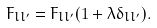<formula> <loc_0><loc_0><loc_500><loc_500>F _ { l l ^ { \prime } } = F _ { l l ^ { \prime } } ( 1 + \lambda \delta _ { l l ^ { \prime } } ) .</formula> 